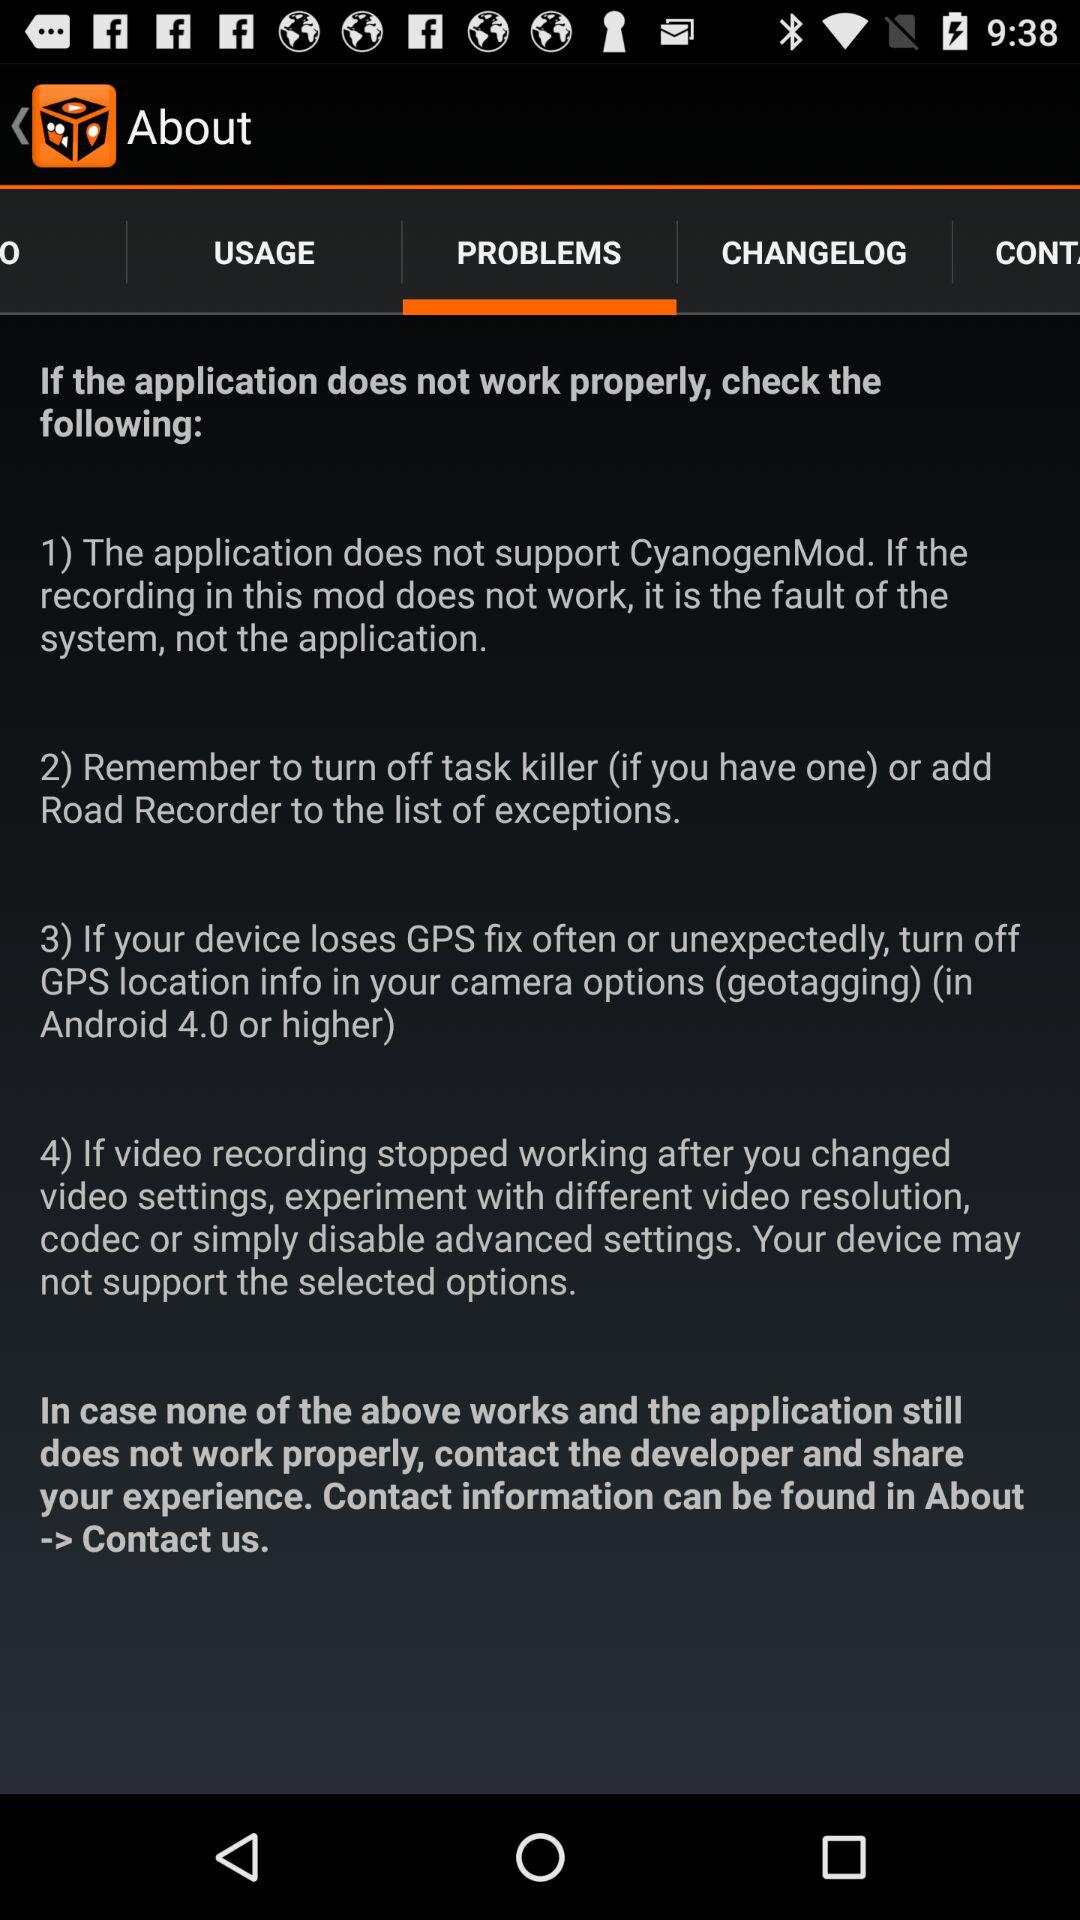How many steps are there in the troubleshooting process?
Answer the question using a single word or phrase. 4 